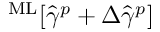<formula> <loc_0><loc_0><loc_500><loc_500>^ { M } L [ \hat { \gamma } ^ { p } + \Delta \hat { \gamma } ^ { p } ]</formula> 